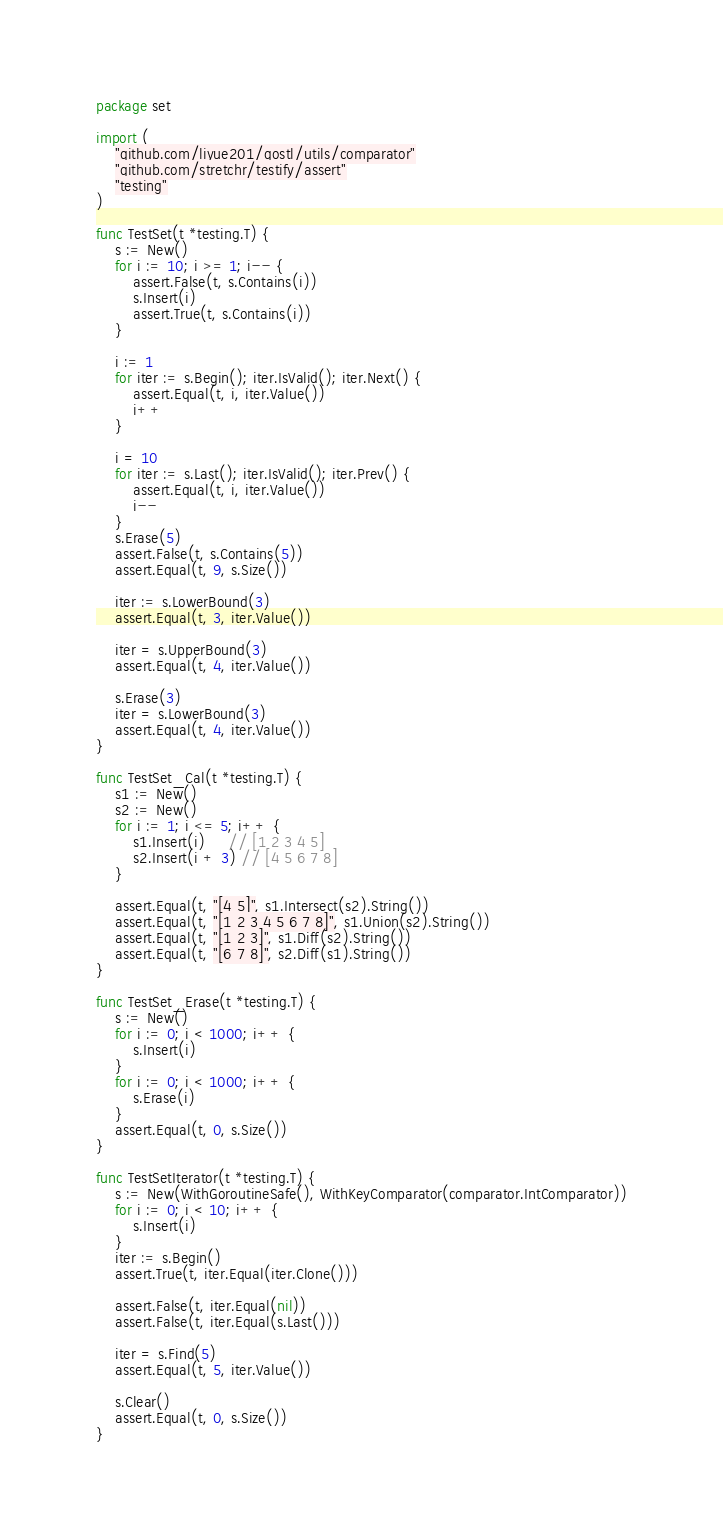Convert code to text. <code><loc_0><loc_0><loc_500><loc_500><_Go_>package set

import (
	"github.com/liyue201/gostl/utils/comparator"
	"github.com/stretchr/testify/assert"
	"testing"
)

func TestSet(t *testing.T) {
	s := New()
	for i := 10; i >= 1; i-- {
		assert.False(t, s.Contains(i))
		s.Insert(i)
		assert.True(t, s.Contains(i))
	}

	i := 1
	for iter := s.Begin(); iter.IsValid(); iter.Next() {
		assert.Equal(t, i, iter.Value())
		i++
	}

	i = 10
	for iter := s.Last(); iter.IsValid(); iter.Prev() {
		assert.Equal(t, i, iter.Value())
		i--
	}
	s.Erase(5)
	assert.False(t, s.Contains(5))
	assert.Equal(t, 9, s.Size())

	iter := s.LowerBound(3)
	assert.Equal(t, 3, iter.Value())

	iter = s.UpperBound(3)
	assert.Equal(t, 4, iter.Value())

	s.Erase(3)
	iter = s.LowerBound(3)
	assert.Equal(t, 4, iter.Value())
}

func TestSet_Cal(t *testing.T) {
	s1 := New()
	s2 := New()
	for i := 1; i <= 5; i++ {
		s1.Insert(i)     // [1 2 3 4 5]
		s2.Insert(i + 3) // [4 5 6 7 8]
	}

	assert.Equal(t, "[4 5]", s1.Intersect(s2).String())
	assert.Equal(t, "[1 2 3 4 5 6 7 8]", s1.Union(s2).String())
	assert.Equal(t, "[1 2 3]", s1.Diff(s2).String())
	assert.Equal(t, "[6 7 8]", s2.Diff(s1).String())
}

func TestSet_Erase(t *testing.T) {
	s := New()
	for i := 0; i < 1000; i++ {
		s.Insert(i)
	}
	for i := 0; i < 1000; i++ {
		s.Erase(i)
	}
	assert.Equal(t, 0, s.Size())
}

func TestSetIterator(t *testing.T) {
	s := New(WithGoroutineSafe(), WithKeyComparator(comparator.IntComparator))
	for i := 0; i < 10; i++ {
		s.Insert(i)
	}
	iter := s.Begin()
	assert.True(t, iter.Equal(iter.Clone()))

	assert.False(t, iter.Equal(nil))
	assert.False(t, iter.Equal(s.Last()))

	iter = s.Find(5)
	assert.Equal(t, 5, iter.Value())

	s.Clear()
	assert.Equal(t, 0, s.Size())
}
</code> 